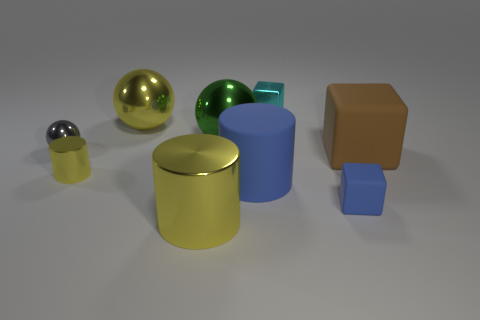Subtract all cylinders. How many objects are left? 6 Add 3 large green balls. How many large green balls are left? 4 Add 6 small blue rubber cylinders. How many small blue rubber cylinders exist? 6 Subtract 0 cyan cylinders. How many objects are left? 9 Subtract all gray shiny balls. Subtract all tiny shiny balls. How many objects are left? 7 